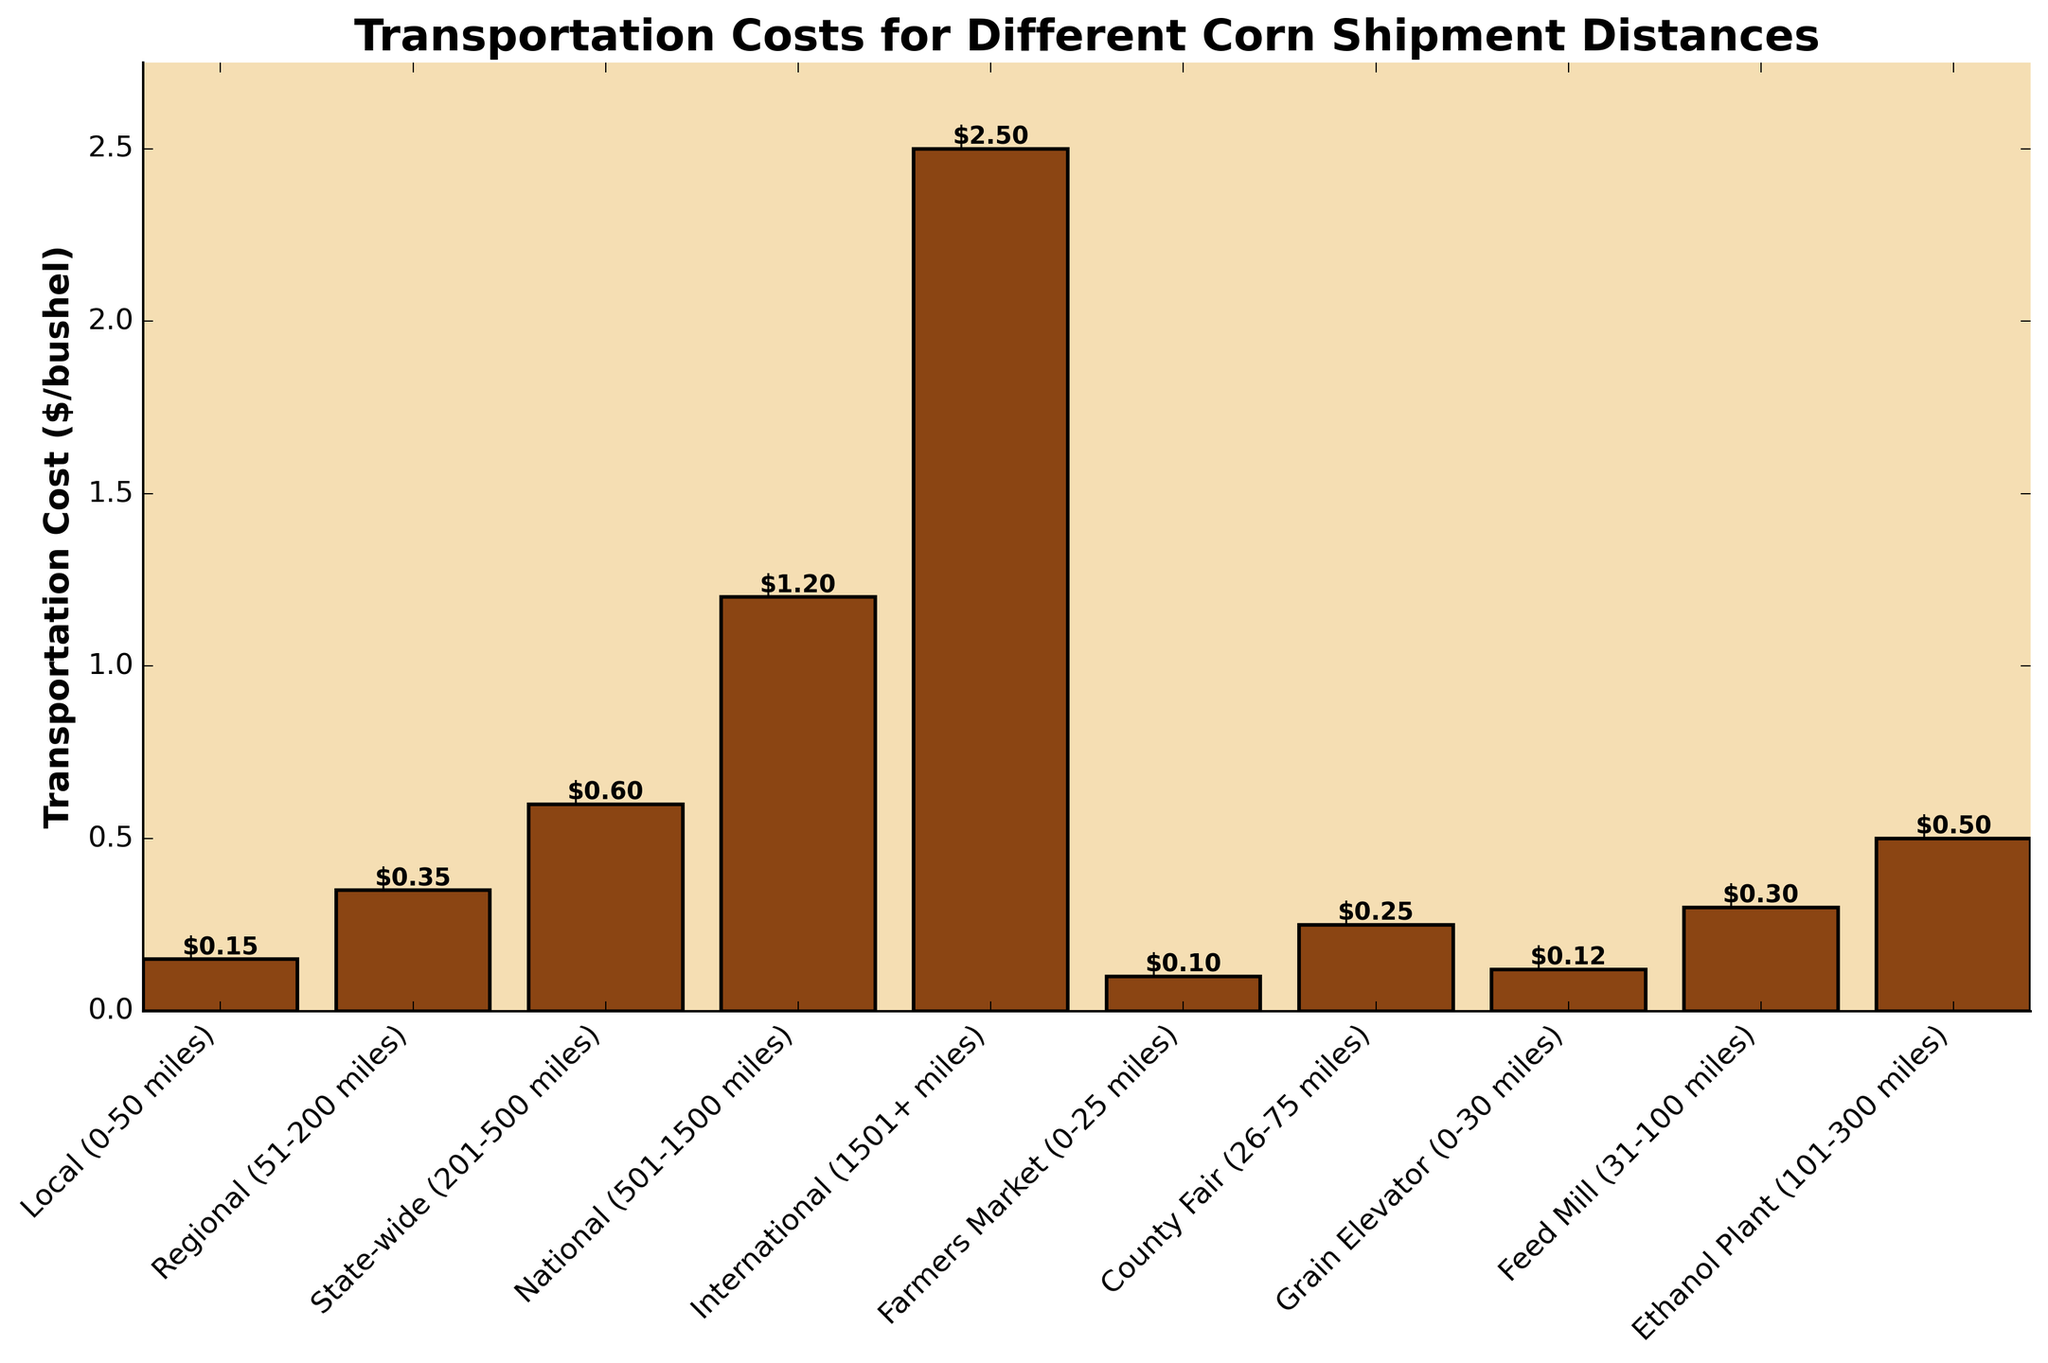What is the transportation cost for local (0-50 miles) shipments? The bar labeled "Local (0-50 miles)" shows a cost of $0.15 per bushel.
Answer: $0.15 Which distance category has the highest transportation cost? The "International (1501+ miles)" category has the highest bar, indicating it has the highest transportation cost at $2.50 per bushel.
Answer: International (1501+ miles) How much more expensive is shipping corn nationally compared to regionally? The national transportation cost is $1.20 per bushel, and the regional transportation cost is $0.35 per bushel. The difference is $1.20 - $0.35 = $0.85 per bushel.
Answer: $0.85 What is the difference in cost between the cheapest and most expensive transportation distances? The cheapest cost is for "Farmers Market (0-25 miles)" at $0.10 per bushel, and the most expensive is "International (1501+ miles)" at $2.50 per bushel. The difference is $2.50 - $0.10 = $2.40 per bushel.
Answer: $2.40 Are the costs for regional shipments and feed mill shipments equal? The cost for regional shipments is $0.35 per bushel, and the cost for feed mill shipments is $0.30 per bushel. They are not equal; regional shipments cost more.
Answer: No On average, how much does it cost to ship corn locally, regionally, and state-wide? The costs are: Local (0-50 miles) $0.15, Regional (51-200 miles) $0.35, State-wide (201-500 miles) $0.60. The average is ($0.15 + $0.35 + $0.60) / 3 = $0.3667 per bushel.
Answer: $0.37 Which distance categories have transportation costs below $0.50 per bushel? The distance categories with costs below $0.50 per bushel are: Local (0-50 miles) $0.15, Regional (51-200 miles) $0.35, Farmers Market (0-25 miles) $0.10, County Fair (26-75 miles) $0.25, Grain Elevator (0-30 miles) $0.12, Feed Mill (31-100 miles) $0.30.
Answer: Local, Regional, Farmers Market, County Fair, Grain Elevator, Feed Mill What percentage of the transportation cost for international shipments is the transportation cost for ethanol plant shipments? The international cost is $2.50, and the ethanol plant cost is $0.50. The percentage is ($0.50 / $2.50) * 100 = 20%.
Answer: 20% Is the cost of shipping to a county fair higher or lower than the cost of shipping to a feed mill? The cost to a county fair is $0.25 per bushel, and to a feed mill is $0.30 per bushel. The cost to a county fair is lower.
Answer: Lower 